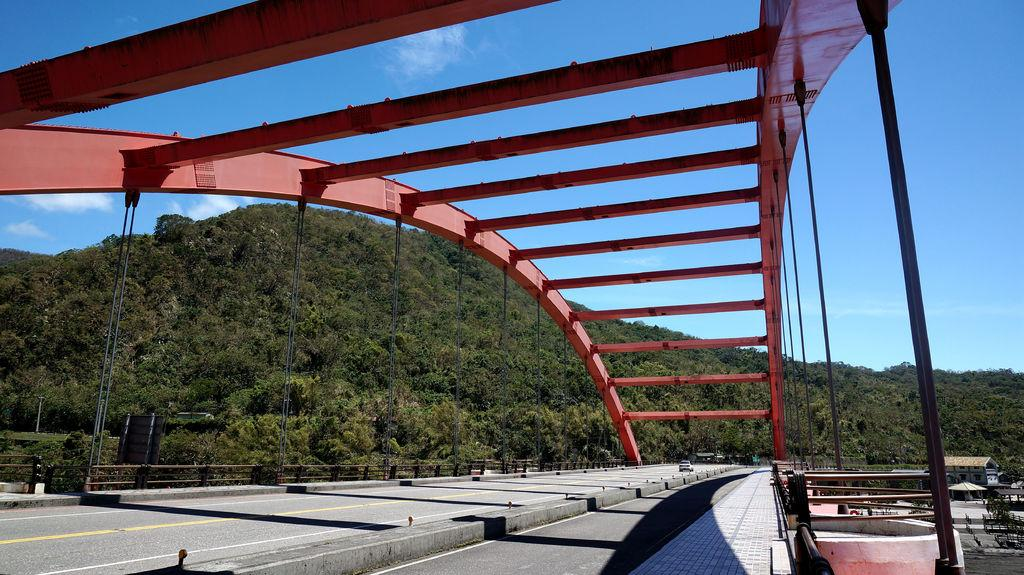What type of structure can be seen in the image? There is a bridge in the image. What other man-made structures are visible in the image? There is architecture in the image. What can be seen in the foreground of the image? Wires are present in the foreground of the image. What type of transportation is visible in the image? There are boats on the water in the image. What type of natural features can be seen in the background of the image? There are mountains in the background of the image. What else is visible in the background of the image? There are houses and the sky in the background of the image. How many cows are grazing on the bridge in the image? There are no cows present in the image; the bridge is not a grazing area for cows. What type of drum is being played by the person on the boat in the image? There is no person playing a drum on a boat in the image. 